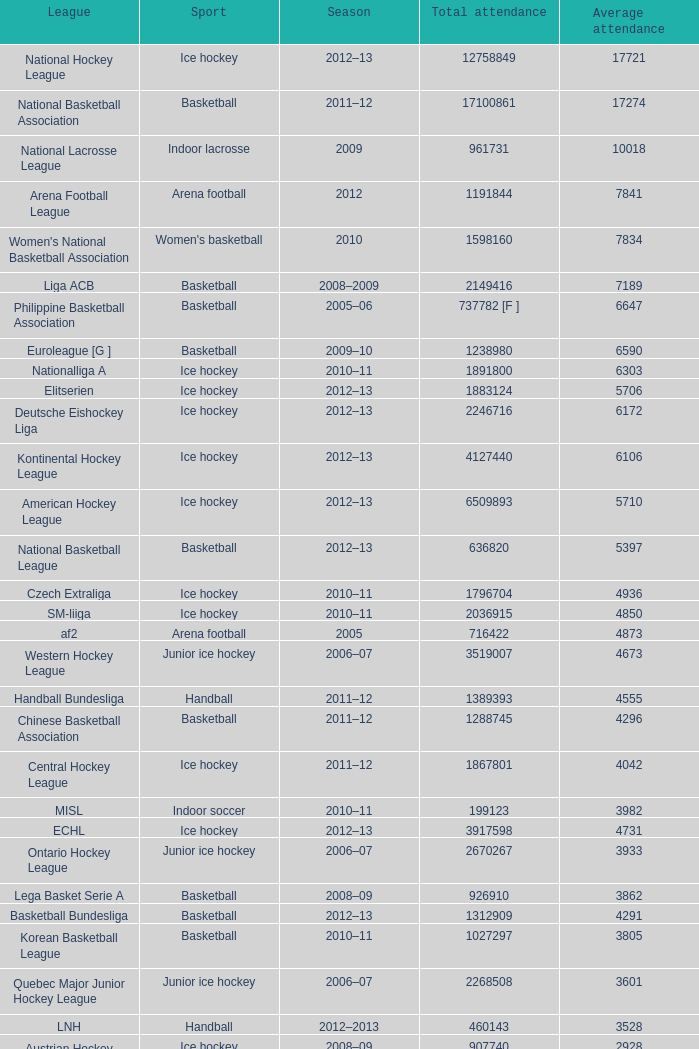In the 2009 season, what was the highest average number of attendees? 10018.0. 